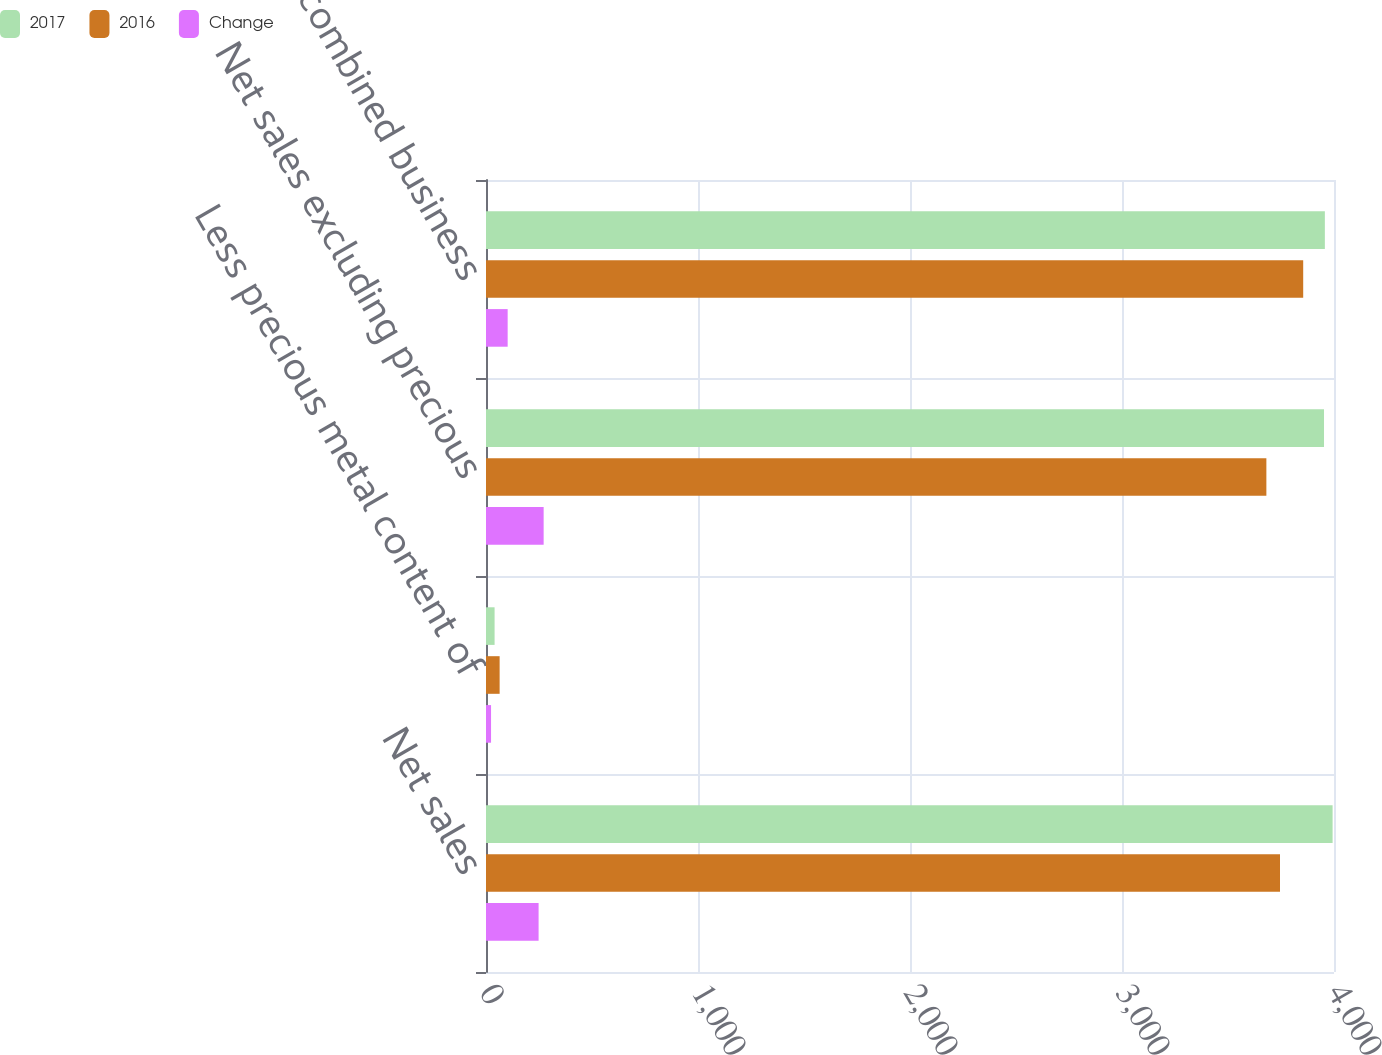<chart> <loc_0><loc_0><loc_500><loc_500><stacked_bar_chart><ecel><fcel>Net sales<fcel>Less precious metal content of<fcel>Net sales excluding precious<fcel>Non-US GAAP combined business<nl><fcel>2017<fcel>3993.4<fcel>40.5<fcel>3952.9<fcel>3956.9<nl><fcel>2016<fcel>3745.3<fcel>64.3<fcel>3681<fcel>3854.7<nl><fcel>Change<fcel>248.1<fcel>23.8<fcel>271.9<fcel>102.2<nl></chart> 